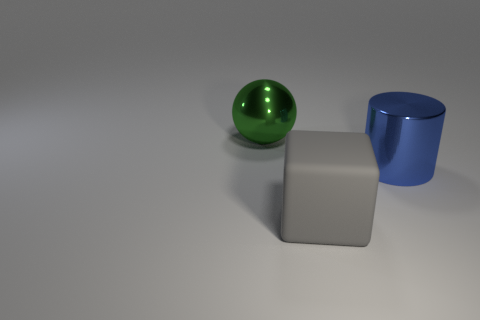Add 3 small green metallic balls. How many objects exist? 6 Subtract all spheres. How many objects are left? 2 Add 2 large spheres. How many large spheres are left? 3 Add 3 small gray shiny cylinders. How many small gray shiny cylinders exist? 3 Subtract 0 yellow cylinders. How many objects are left? 3 Subtract all shiny balls. Subtract all gray metal cylinders. How many objects are left? 2 